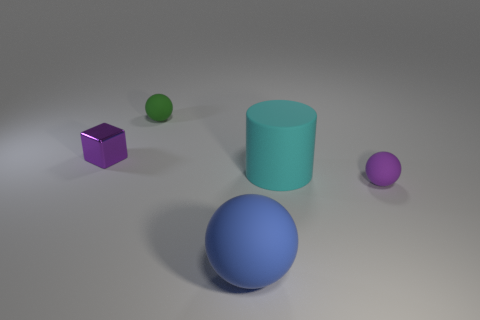Add 4 big brown matte spheres. How many objects exist? 9 Subtract all cylinders. How many objects are left? 4 Add 2 tiny purple rubber cubes. How many tiny purple rubber cubes exist? 2 Subtract 0 yellow cylinders. How many objects are left? 5 Subtract all big matte objects. Subtract all cyan matte things. How many objects are left? 2 Add 5 purple blocks. How many purple blocks are left? 6 